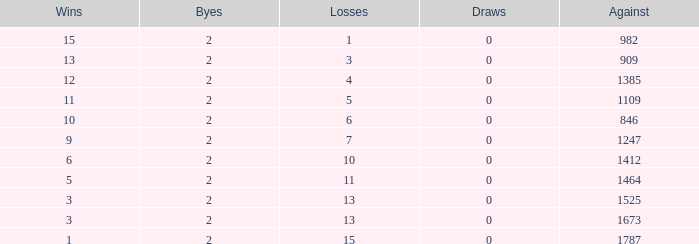In cases where there were fewer than 0 losses and 1247 opponents, what was the usual number of byes? None. 